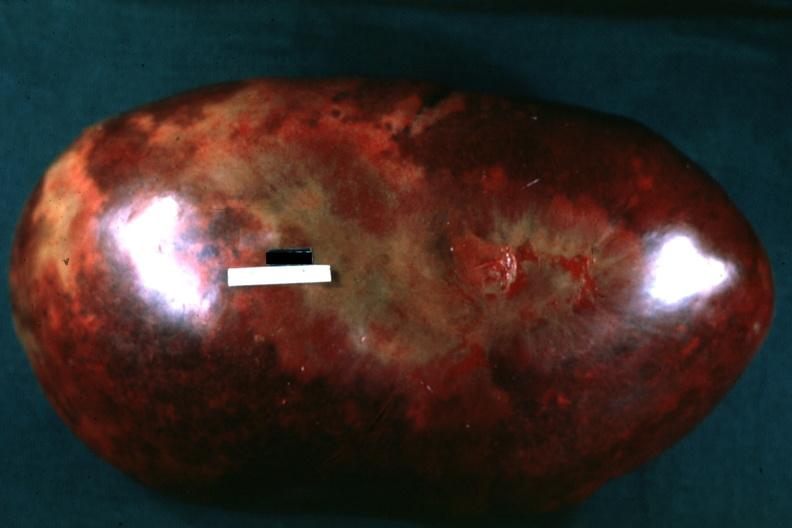s hematologic present?
Answer the question using a single word or phrase. Yes 